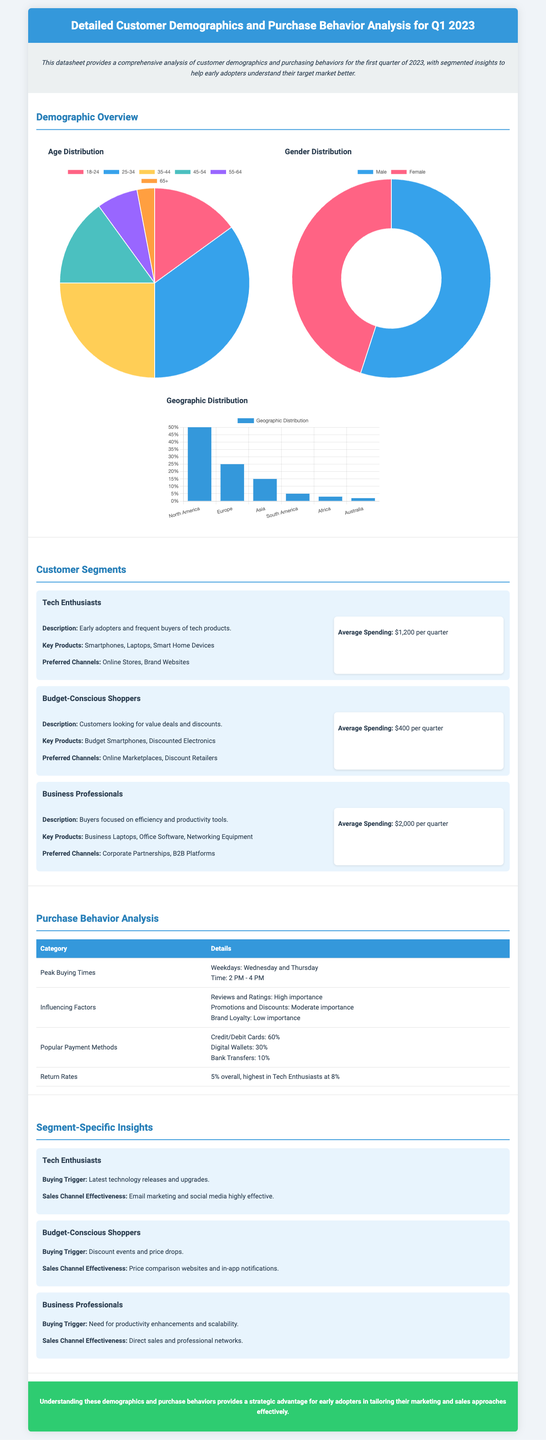What is the average spending of Tech Enthusiasts? The average spending for Tech Enthusiasts is mentioned in the document.
Answer: $1,200 per quarter What percentage of customers are Female? The gender distribution chart provides the percentage of female customers.
Answer: 45% Which segment spends the most on average? The document specifies the average spending for each customer segment.
Answer: Business Professionals What time is peak buying activity noted in the document? The section on purchase behavior indicates the peak buying times.
Answer: 2 PM - 4 PM What is the overall return rate mentioned? The return rates are quantified in the document.
Answer: 5% What key products do Budget-Conscious Shoppers prefer? The segment-specific insights include the key products for this group.
Answer: Budget Smartphones, Discounted Electronics What is the dominant payment method according to the analysis? The document lists popular payment methods, indicating their usage percentages.
Answer: Credit/Debit Cards What is the buying trigger for Business Professionals? The document provides insights regarding what triggers purchases for this segment.
Answer: Need for productivity enhancements and scalability What age group constitutes the largest segment? The age distribution chart offers information on customer age groups.
Answer: 25-34 